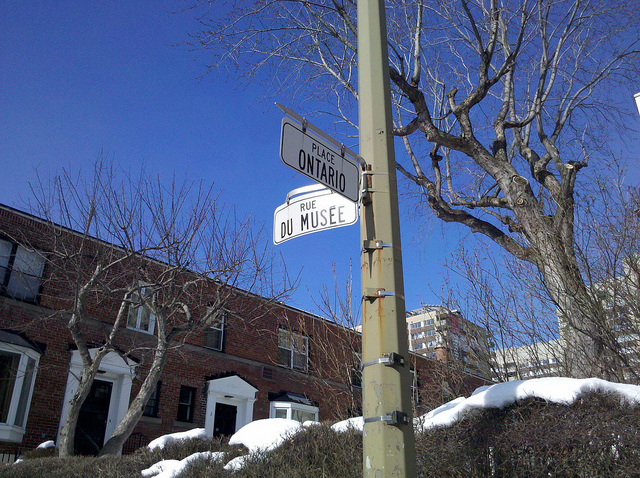Please extract the text content from this image. PLACE ONTARO RUE DU MUSEE 